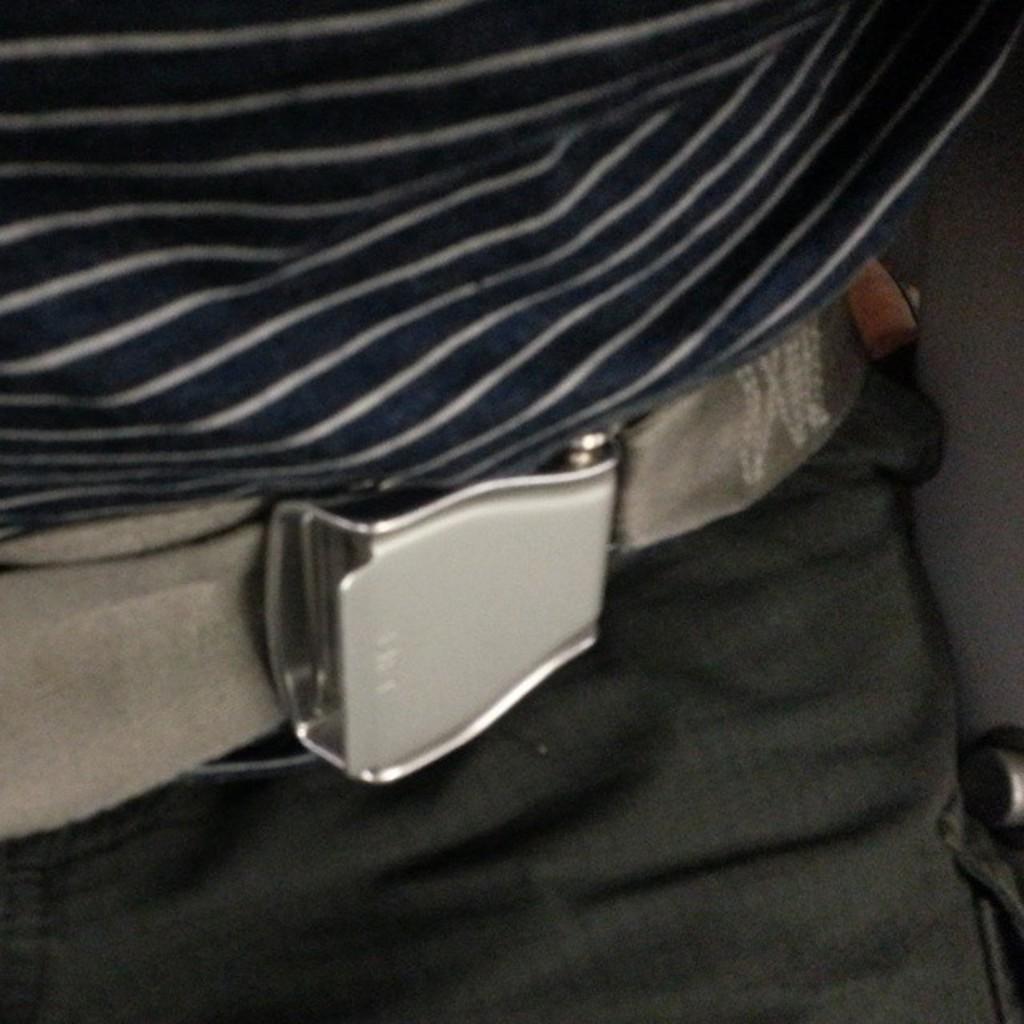Describe this image in one or two sentences. In this picture there is a belt in the center of the image. 